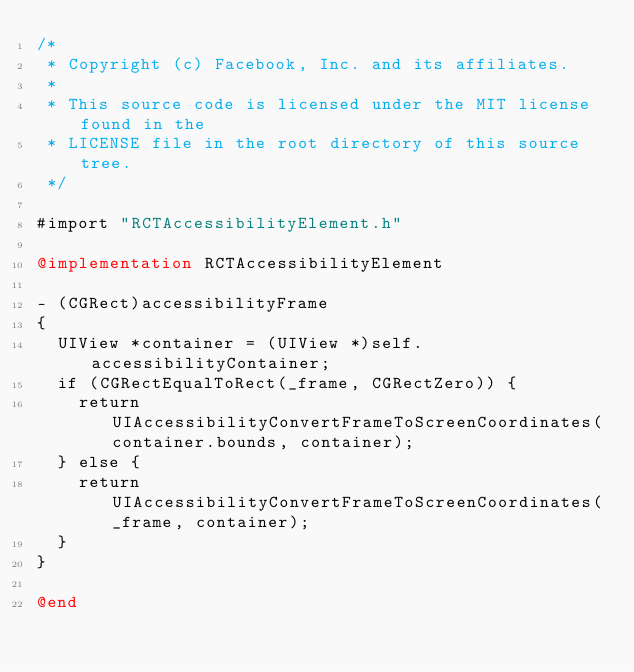Convert code to text. <code><loc_0><loc_0><loc_500><loc_500><_ObjectiveC_>/*
 * Copyright (c) Facebook, Inc. and its affiliates.
 *
 * This source code is licensed under the MIT license found in the
 * LICENSE file in the root directory of this source tree.
 */

#import "RCTAccessibilityElement.h"

@implementation RCTAccessibilityElement

- (CGRect)accessibilityFrame
{
  UIView *container = (UIView *)self.accessibilityContainer;
  if (CGRectEqualToRect(_frame, CGRectZero)) {
    return UIAccessibilityConvertFrameToScreenCoordinates(container.bounds, container);
  } else {
    return UIAccessibilityConvertFrameToScreenCoordinates(_frame, container);
  }
}

@end
</code> 